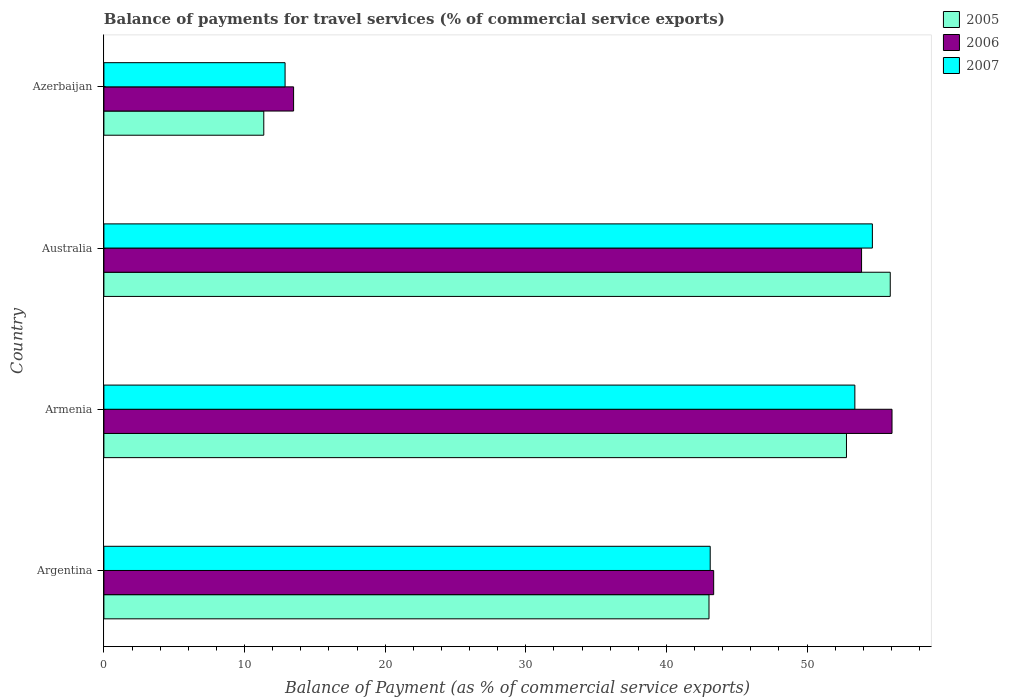How many different coloured bars are there?
Provide a short and direct response. 3. How many bars are there on the 2nd tick from the top?
Make the answer very short. 3. How many bars are there on the 3rd tick from the bottom?
Keep it short and to the point. 3. What is the label of the 2nd group of bars from the top?
Provide a succinct answer. Australia. In how many cases, is the number of bars for a given country not equal to the number of legend labels?
Ensure brevity in your answer.  0. What is the balance of payments for travel services in 2005 in Australia?
Offer a very short reply. 55.91. Across all countries, what is the maximum balance of payments for travel services in 2005?
Your response must be concise. 55.91. Across all countries, what is the minimum balance of payments for travel services in 2007?
Make the answer very short. 12.88. In which country was the balance of payments for travel services in 2006 maximum?
Your answer should be very brief. Armenia. In which country was the balance of payments for travel services in 2005 minimum?
Ensure brevity in your answer.  Azerbaijan. What is the total balance of payments for travel services in 2006 in the graph?
Make the answer very short. 166.76. What is the difference between the balance of payments for travel services in 2005 in Armenia and that in Azerbaijan?
Offer a very short reply. 41.43. What is the difference between the balance of payments for travel services in 2005 in Argentina and the balance of payments for travel services in 2006 in Azerbaijan?
Offer a terse response. 29.54. What is the average balance of payments for travel services in 2005 per country?
Ensure brevity in your answer.  40.78. What is the difference between the balance of payments for travel services in 2007 and balance of payments for travel services in 2006 in Azerbaijan?
Ensure brevity in your answer.  -0.61. What is the ratio of the balance of payments for travel services in 2006 in Armenia to that in Azerbaijan?
Keep it short and to the point. 4.15. Is the balance of payments for travel services in 2007 in Armenia less than that in Australia?
Offer a very short reply. Yes. Is the difference between the balance of payments for travel services in 2007 in Armenia and Azerbaijan greater than the difference between the balance of payments for travel services in 2006 in Armenia and Azerbaijan?
Your answer should be very brief. No. What is the difference between the highest and the second highest balance of payments for travel services in 2005?
Keep it short and to the point. 3.11. What is the difference between the highest and the lowest balance of payments for travel services in 2007?
Your response must be concise. 41.76. What does the 3rd bar from the top in Argentina represents?
Offer a very short reply. 2005. How many bars are there?
Give a very brief answer. 12. How many countries are there in the graph?
Ensure brevity in your answer.  4. What is the difference between two consecutive major ticks on the X-axis?
Give a very brief answer. 10. Does the graph contain grids?
Your response must be concise. No. What is the title of the graph?
Your answer should be compact. Balance of payments for travel services (% of commercial service exports). What is the label or title of the X-axis?
Offer a terse response. Balance of Payment (as % of commercial service exports). What is the Balance of Payment (as % of commercial service exports) in 2005 in Argentina?
Your answer should be compact. 43.03. What is the Balance of Payment (as % of commercial service exports) in 2006 in Argentina?
Give a very brief answer. 43.36. What is the Balance of Payment (as % of commercial service exports) of 2007 in Argentina?
Give a very brief answer. 43.11. What is the Balance of Payment (as % of commercial service exports) in 2005 in Armenia?
Your answer should be compact. 52.8. What is the Balance of Payment (as % of commercial service exports) in 2006 in Armenia?
Keep it short and to the point. 56.04. What is the Balance of Payment (as % of commercial service exports) of 2007 in Armenia?
Make the answer very short. 53.4. What is the Balance of Payment (as % of commercial service exports) in 2005 in Australia?
Make the answer very short. 55.91. What is the Balance of Payment (as % of commercial service exports) of 2006 in Australia?
Give a very brief answer. 53.87. What is the Balance of Payment (as % of commercial service exports) in 2007 in Australia?
Offer a terse response. 54.64. What is the Balance of Payment (as % of commercial service exports) in 2005 in Azerbaijan?
Provide a succinct answer. 11.37. What is the Balance of Payment (as % of commercial service exports) in 2006 in Azerbaijan?
Provide a short and direct response. 13.49. What is the Balance of Payment (as % of commercial service exports) in 2007 in Azerbaijan?
Provide a succinct answer. 12.88. Across all countries, what is the maximum Balance of Payment (as % of commercial service exports) of 2005?
Your response must be concise. 55.91. Across all countries, what is the maximum Balance of Payment (as % of commercial service exports) of 2006?
Offer a terse response. 56.04. Across all countries, what is the maximum Balance of Payment (as % of commercial service exports) of 2007?
Offer a terse response. 54.64. Across all countries, what is the minimum Balance of Payment (as % of commercial service exports) of 2005?
Give a very brief answer. 11.37. Across all countries, what is the minimum Balance of Payment (as % of commercial service exports) of 2006?
Your response must be concise. 13.49. Across all countries, what is the minimum Balance of Payment (as % of commercial service exports) in 2007?
Keep it short and to the point. 12.88. What is the total Balance of Payment (as % of commercial service exports) in 2005 in the graph?
Provide a succinct answer. 163.11. What is the total Balance of Payment (as % of commercial service exports) in 2006 in the graph?
Your answer should be very brief. 166.76. What is the total Balance of Payment (as % of commercial service exports) of 2007 in the graph?
Make the answer very short. 164.04. What is the difference between the Balance of Payment (as % of commercial service exports) in 2005 in Argentina and that in Armenia?
Make the answer very short. -9.77. What is the difference between the Balance of Payment (as % of commercial service exports) in 2006 in Argentina and that in Armenia?
Your answer should be compact. -12.68. What is the difference between the Balance of Payment (as % of commercial service exports) in 2007 in Argentina and that in Armenia?
Make the answer very short. -10.29. What is the difference between the Balance of Payment (as % of commercial service exports) of 2005 in Argentina and that in Australia?
Provide a short and direct response. -12.89. What is the difference between the Balance of Payment (as % of commercial service exports) of 2006 in Argentina and that in Australia?
Provide a short and direct response. -10.52. What is the difference between the Balance of Payment (as % of commercial service exports) in 2007 in Argentina and that in Australia?
Offer a terse response. -11.53. What is the difference between the Balance of Payment (as % of commercial service exports) in 2005 in Argentina and that in Azerbaijan?
Give a very brief answer. 31.66. What is the difference between the Balance of Payment (as % of commercial service exports) in 2006 in Argentina and that in Azerbaijan?
Provide a short and direct response. 29.87. What is the difference between the Balance of Payment (as % of commercial service exports) of 2007 in Argentina and that in Azerbaijan?
Offer a very short reply. 30.23. What is the difference between the Balance of Payment (as % of commercial service exports) in 2005 in Armenia and that in Australia?
Provide a succinct answer. -3.11. What is the difference between the Balance of Payment (as % of commercial service exports) in 2006 in Armenia and that in Australia?
Offer a very short reply. 2.17. What is the difference between the Balance of Payment (as % of commercial service exports) in 2007 in Armenia and that in Australia?
Keep it short and to the point. -1.25. What is the difference between the Balance of Payment (as % of commercial service exports) of 2005 in Armenia and that in Azerbaijan?
Give a very brief answer. 41.43. What is the difference between the Balance of Payment (as % of commercial service exports) in 2006 in Armenia and that in Azerbaijan?
Make the answer very short. 42.55. What is the difference between the Balance of Payment (as % of commercial service exports) of 2007 in Armenia and that in Azerbaijan?
Provide a succinct answer. 40.51. What is the difference between the Balance of Payment (as % of commercial service exports) in 2005 in Australia and that in Azerbaijan?
Your response must be concise. 44.55. What is the difference between the Balance of Payment (as % of commercial service exports) of 2006 in Australia and that in Azerbaijan?
Offer a terse response. 40.39. What is the difference between the Balance of Payment (as % of commercial service exports) of 2007 in Australia and that in Azerbaijan?
Provide a succinct answer. 41.76. What is the difference between the Balance of Payment (as % of commercial service exports) of 2005 in Argentina and the Balance of Payment (as % of commercial service exports) of 2006 in Armenia?
Make the answer very short. -13.01. What is the difference between the Balance of Payment (as % of commercial service exports) of 2005 in Argentina and the Balance of Payment (as % of commercial service exports) of 2007 in Armenia?
Give a very brief answer. -10.37. What is the difference between the Balance of Payment (as % of commercial service exports) in 2006 in Argentina and the Balance of Payment (as % of commercial service exports) in 2007 in Armenia?
Provide a succinct answer. -10.04. What is the difference between the Balance of Payment (as % of commercial service exports) of 2005 in Argentina and the Balance of Payment (as % of commercial service exports) of 2006 in Australia?
Offer a terse response. -10.85. What is the difference between the Balance of Payment (as % of commercial service exports) of 2005 in Argentina and the Balance of Payment (as % of commercial service exports) of 2007 in Australia?
Provide a short and direct response. -11.62. What is the difference between the Balance of Payment (as % of commercial service exports) of 2006 in Argentina and the Balance of Payment (as % of commercial service exports) of 2007 in Australia?
Make the answer very short. -11.29. What is the difference between the Balance of Payment (as % of commercial service exports) of 2005 in Argentina and the Balance of Payment (as % of commercial service exports) of 2006 in Azerbaijan?
Your response must be concise. 29.54. What is the difference between the Balance of Payment (as % of commercial service exports) of 2005 in Argentina and the Balance of Payment (as % of commercial service exports) of 2007 in Azerbaijan?
Your response must be concise. 30.14. What is the difference between the Balance of Payment (as % of commercial service exports) in 2006 in Argentina and the Balance of Payment (as % of commercial service exports) in 2007 in Azerbaijan?
Provide a short and direct response. 30.47. What is the difference between the Balance of Payment (as % of commercial service exports) of 2005 in Armenia and the Balance of Payment (as % of commercial service exports) of 2006 in Australia?
Your answer should be very brief. -1.07. What is the difference between the Balance of Payment (as % of commercial service exports) in 2005 in Armenia and the Balance of Payment (as % of commercial service exports) in 2007 in Australia?
Provide a short and direct response. -1.84. What is the difference between the Balance of Payment (as % of commercial service exports) of 2006 in Armenia and the Balance of Payment (as % of commercial service exports) of 2007 in Australia?
Your answer should be compact. 1.4. What is the difference between the Balance of Payment (as % of commercial service exports) of 2005 in Armenia and the Balance of Payment (as % of commercial service exports) of 2006 in Azerbaijan?
Make the answer very short. 39.31. What is the difference between the Balance of Payment (as % of commercial service exports) of 2005 in Armenia and the Balance of Payment (as % of commercial service exports) of 2007 in Azerbaijan?
Your response must be concise. 39.92. What is the difference between the Balance of Payment (as % of commercial service exports) in 2006 in Armenia and the Balance of Payment (as % of commercial service exports) in 2007 in Azerbaijan?
Give a very brief answer. 43.16. What is the difference between the Balance of Payment (as % of commercial service exports) of 2005 in Australia and the Balance of Payment (as % of commercial service exports) of 2006 in Azerbaijan?
Ensure brevity in your answer.  42.43. What is the difference between the Balance of Payment (as % of commercial service exports) of 2005 in Australia and the Balance of Payment (as % of commercial service exports) of 2007 in Azerbaijan?
Offer a very short reply. 43.03. What is the difference between the Balance of Payment (as % of commercial service exports) in 2006 in Australia and the Balance of Payment (as % of commercial service exports) in 2007 in Azerbaijan?
Provide a short and direct response. 40.99. What is the average Balance of Payment (as % of commercial service exports) in 2005 per country?
Offer a very short reply. 40.78. What is the average Balance of Payment (as % of commercial service exports) of 2006 per country?
Keep it short and to the point. 41.69. What is the average Balance of Payment (as % of commercial service exports) in 2007 per country?
Offer a very short reply. 41.01. What is the difference between the Balance of Payment (as % of commercial service exports) in 2005 and Balance of Payment (as % of commercial service exports) in 2006 in Argentina?
Offer a terse response. -0.33. What is the difference between the Balance of Payment (as % of commercial service exports) of 2005 and Balance of Payment (as % of commercial service exports) of 2007 in Argentina?
Offer a very short reply. -0.09. What is the difference between the Balance of Payment (as % of commercial service exports) in 2006 and Balance of Payment (as % of commercial service exports) in 2007 in Argentina?
Offer a very short reply. 0.25. What is the difference between the Balance of Payment (as % of commercial service exports) of 2005 and Balance of Payment (as % of commercial service exports) of 2006 in Armenia?
Provide a short and direct response. -3.24. What is the difference between the Balance of Payment (as % of commercial service exports) in 2005 and Balance of Payment (as % of commercial service exports) in 2007 in Armenia?
Offer a terse response. -0.6. What is the difference between the Balance of Payment (as % of commercial service exports) in 2006 and Balance of Payment (as % of commercial service exports) in 2007 in Armenia?
Make the answer very short. 2.64. What is the difference between the Balance of Payment (as % of commercial service exports) in 2005 and Balance of Payment (as % of commercial service exports) in 2006 in Australia?
Your answer should be compact. 2.04. What is the difference between the Balance of Payment (as % of commercial service exports) in 2005 and Balance of Payment (as % of commercial service exports) in 2007 in Australia?
Your answer should be very brief. 1.27. What is the difference between the Balance of Payment (as % of commercial service exports) in 2006 and Balance of Payment (as % of commercial service exports) in 2007 in Australia?
Give a very brief answer. -0.77. What is the difference between the Balance of Payment (as % of commercial service exports) in 2005 and Balance of Payment (as % of commercial service exports) in 2006 in Azerbaijan?
Offer a terse response. -2.12. What is the difference between the Balance of Payment (as % of commercial service exports) in 2005 and Balance of Payment (as % of commercial service exports) in 2007 in Azerbaijan?
Provide a short and direct response. -1.51. What is the difference between the Balance of Payment (as % of commercial service exports) in 2006 and Balance of Payment (as % of commercial service exports) in 2007 in Azerbaijan?
Provide a short and direct response. 0.61. What is the ratio of the Balance of Payment (as % of commercial service exports) of 2005 in Argentina to that in Armenia?
Offer a very short reply. 0.81. What is the ratio of the Balance of Payment (as % of commercial service exports) in 2006 in Argentina to that in Armenia?
Offer a terse response. 0.77. What is the ratio of the Balance of Payment (as % of commercial service exports) in 2007 in Argentina to that in Armenia?
Your response must be concise. 0.81. What is the ratio of the Balance of Payment (as % of commercial service exports) of 2005 in Argentina to that in Australia?
Your response must be concise. 0.77. What is the ratio of the Balance of Payment (as % of commercial service exports) in 2006 in Argentina to that in Australia?
Your answer should be very brief. 0.8. What is the ratio of the Balance of Payment (as % of commercial service exports) of 2007 in Argentina to that in Australia?
Offer a very short reply. 0.79. What is the ratio of the Balance of Payment (as % of commercial service exports) in 2005 in Argentina to that in Azerbaijan?
Provide a succinct answer. 3.78. What is the ratio of the Balance of Payment (as % of commercial service exports) of 2006 in Argentina to that in Azerbaijan?
Give a very brief answer. 3.21. What is the ratio of the Balance of Payment (as % of commercial service exports) in 2007 in Argentina to that in Azerbaijan?
Offer a very short reply. 3.35. What is the ratio of the Balance of Payment (as % of commercial service exports) in 2005 in Armenia to that in Australia?
Give a very brief answer. 0.94. What is the ratio of the Balance of Payment (as % of commercial service exports) in 2006 in Armenia to that in Australia?
Your answer should be compact. 1.04. What is the ratio of the Balance of Payment (as % of commercial service exports) in 2007 in Armenia to that in Australia?
Provide a succinct answer. 0.98. What is the ratio of the Balance of Payment (as % of commercial service exports) in 2005 in Armenia to that in Azerbaijan?
Ensure brevity in your answer.  4.64. What is the ratio of the Balance of Payment (as % of commercial service exports) in 2006 in Armenia to that in Azerbaijan?
Make the answer very short. 4.15. What is the ratio of the Balance of Payment (as % of commercial service exports) in 2007 in Armenia to that in Azerbaijan?
Ensure brevity in your answer.  4.14. What is the ratio of the Balance of Payment (as % of commercial service exports) in 2005 in Australia to that in Azerbaijan?
Your answer should be compact. 4.92. What is the ratio of the Balance of Payment (as % of commercial service exports) of 2006 in Australia to that in Azerbaijan?
Keep it short and to the point. 3.99. What is the ratio of the Balance of Payment (as % of commercial service exports) in 2007 in Australia to that in Azerbaijan?
Make the answer very short. 4.24. What is the difference between the highest and the second highest Balance of Payment (as % of commercial service exports) of 2005?
Your answer should be compact. 3.11. What is the difference between the highest and the second highest Balance of Payment (as % of commercial service exports) of 2006?
Your answer should be compact. 2.17. What is the difference between the highest and the second highest Balance of Payment (as % of commercial service exports) of 2007?
Offer a terse response. 1.25. What is the difference between the highest and the lowest Balance of Payment (as % of commercial service exports) in 2005?
Your response must be concise. 44.55. What is the difference between the highest and the lowest Balance of Payment (as % of commercial service exports) in 2006?
Ensure brevity in your answer.  42.55. What is the difference between the highest and the lowest Balance of Payment (as % of commercial service exports) in 2007?
Your response must be concise. 41.76. 